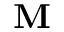<formula> <loc_0><loc_0><loc_500><loc_500>\mathbf M</formula> 